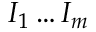Convert formula to latex. <formula><loc_0><loc_0><loc_500><loc_500>I _ { 1 } \dots I _ { m }</formula> 